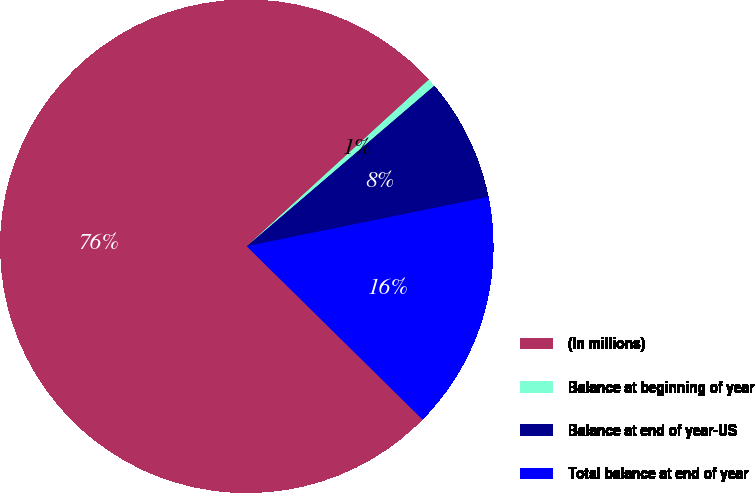Convert chart to OTSL. <chart><loc_0><loc_0><loc_500><loc_500><pie_chart><fcel>(In millions)<fcel>Balance at beginning of year<fcel>Balance at end of year-US<fcel>Total balance at end of year<nl><fcel>75.82%<fcel>0.53%<fcel>8.06%<fcel>15.59%<nl></chart> 